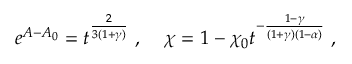<formula> <loc_0><loc_0><loc_500><loc_500>e ^ { A - A _ { 0 } } = t ^ { \frac { 2 } { 3 ( 1 + \gamma ) } } \, , \, \chi = 1 - \chi _ { 0 } t ^ { - \frac { 1 - \gamma } { ( 1 + \gamma ) ( 1 - \alpha ) } } \, ,</formula> 